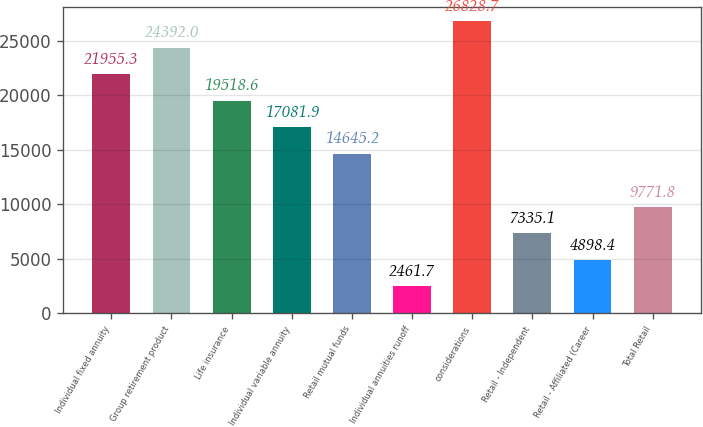Convert chart. <chart><loc_0><loc_0><loc_500><loc_500><bar_chart><fcel>Individual fixed annuity<fcel>Group retirement product<fcel>Life insurance<fcel>Individual variable annuity<fcel>Retail mutual funds<fcel>Individual annuities runoff<fcel>considerations<fcel>Retail - Independent<fcel>Retail - Affiliated (Career<fcel>Total Retail<nl><fcel>21955.3<fcel>24392<fcel>19518.6<fcel>17081.9<fcel>14645.2<fcel>2461.7<fcel>26828.7<fcel>7335.1<fcel>4898.4<fcel>9771.8<nl></chart> 